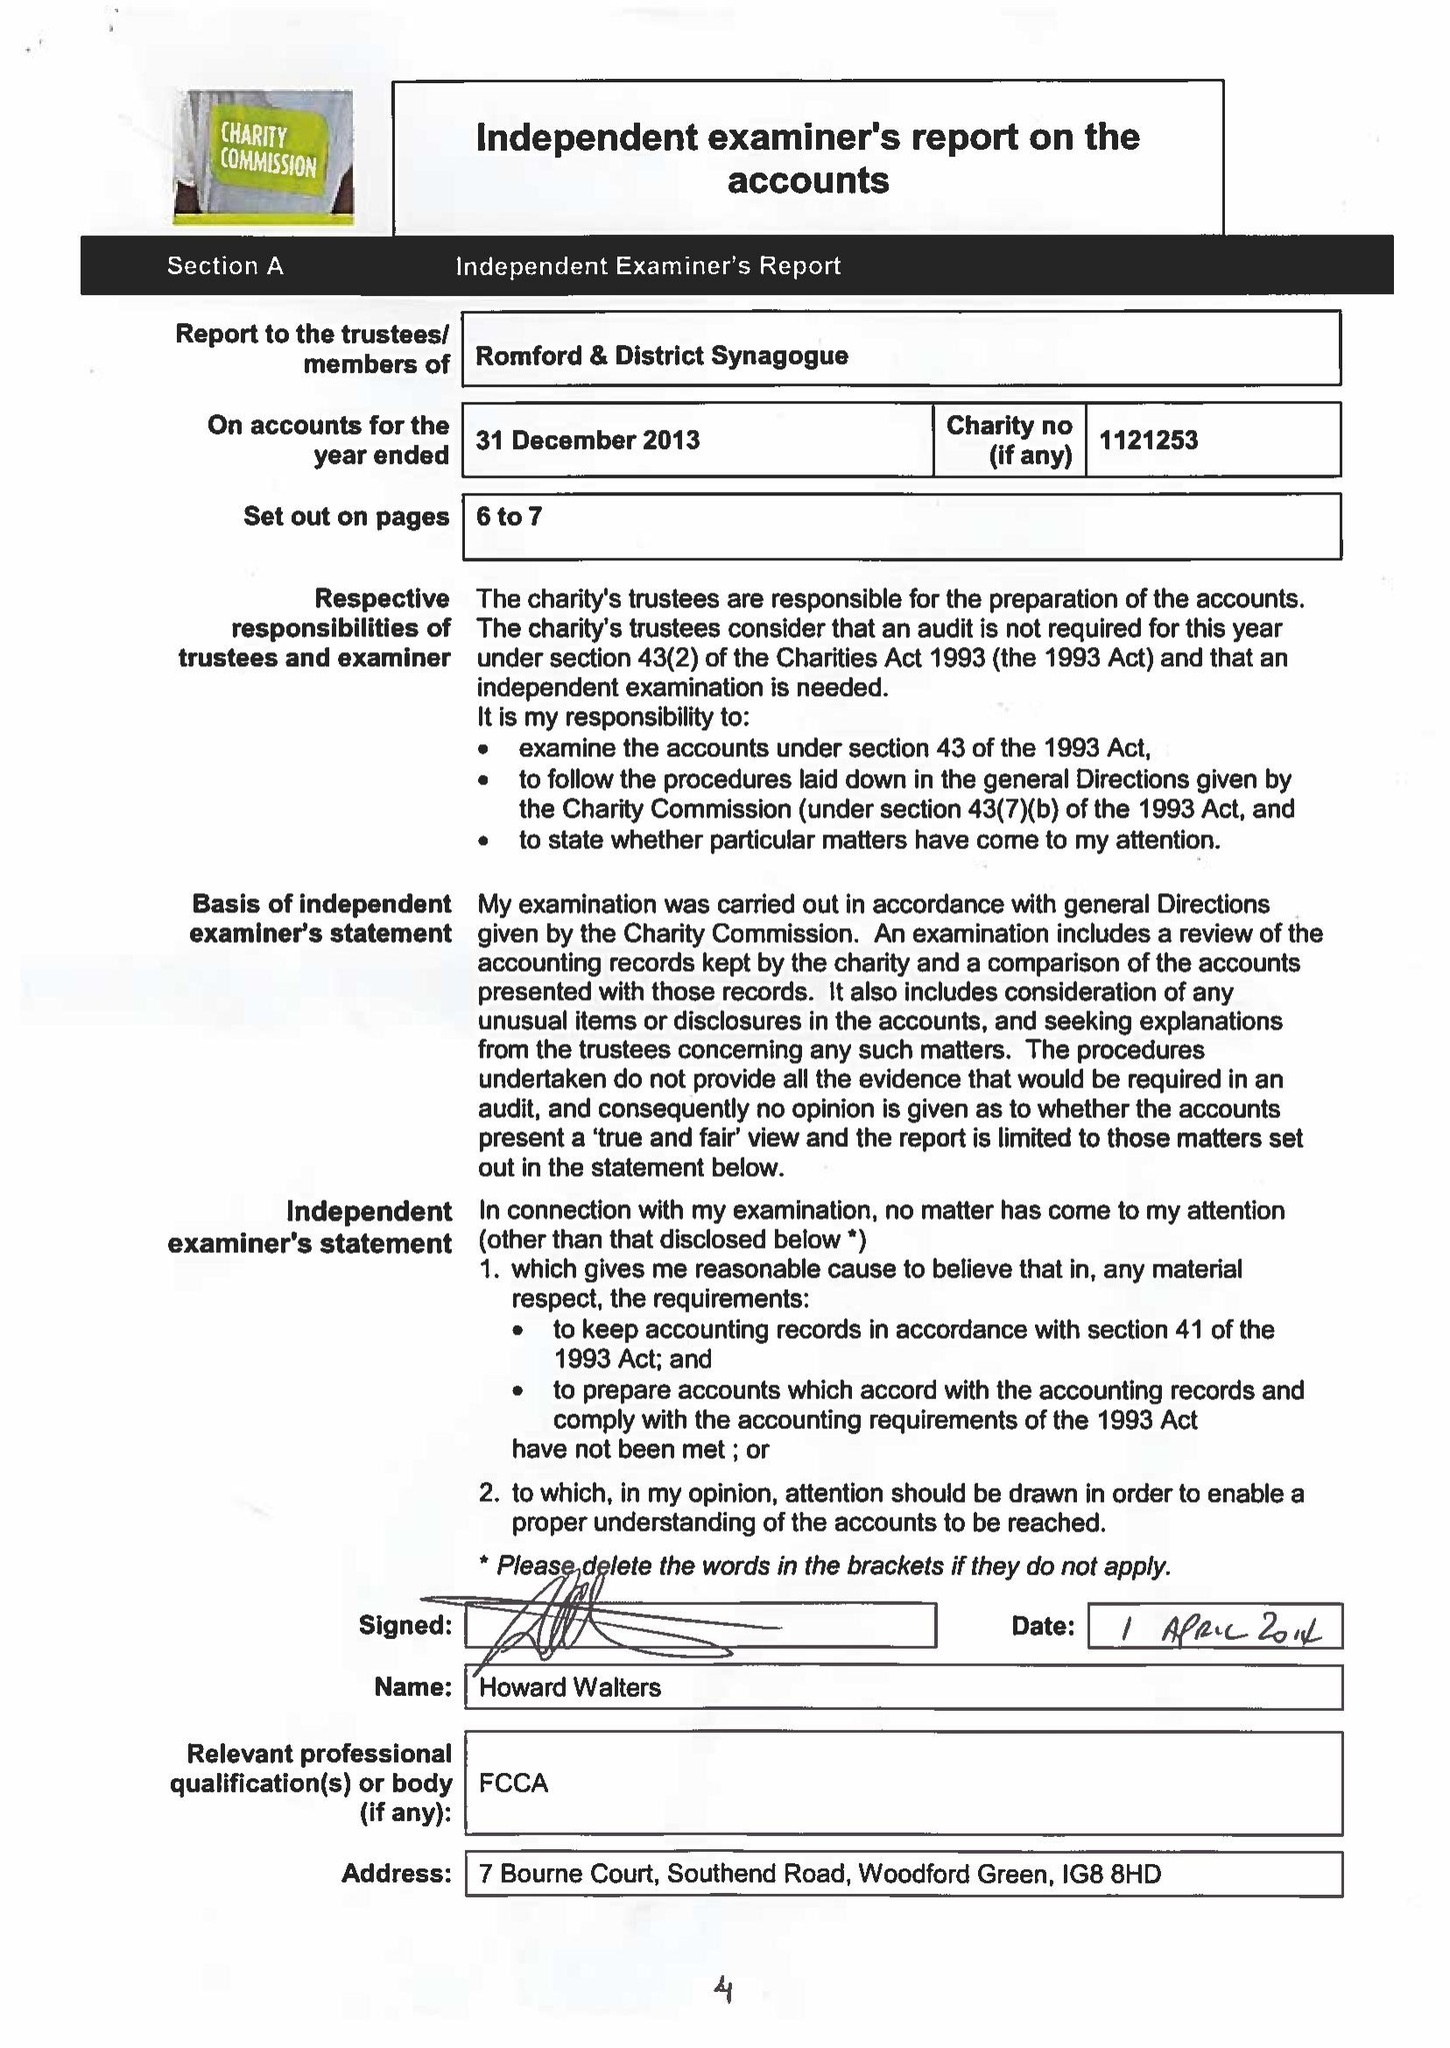What is the value for the address__postcode?
Answer the question using a single word or phrase. RM1 3NH 